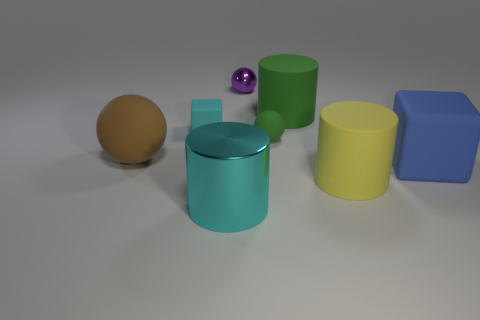Add 2 green matte things. How many objects exist? 10 Subtract all cubes. How many objects are left? 6 Subtract 0 purple blocks. How many objects are left? 8 Subtract all big objects. Subtract all cyan shiny spheres. How many objects are left? 3 Add 7 yellow rubber cylinders. How many yellow rubber cylinders are left? 8 Add 4 big cyan things. How many big cyan things exist? 5 